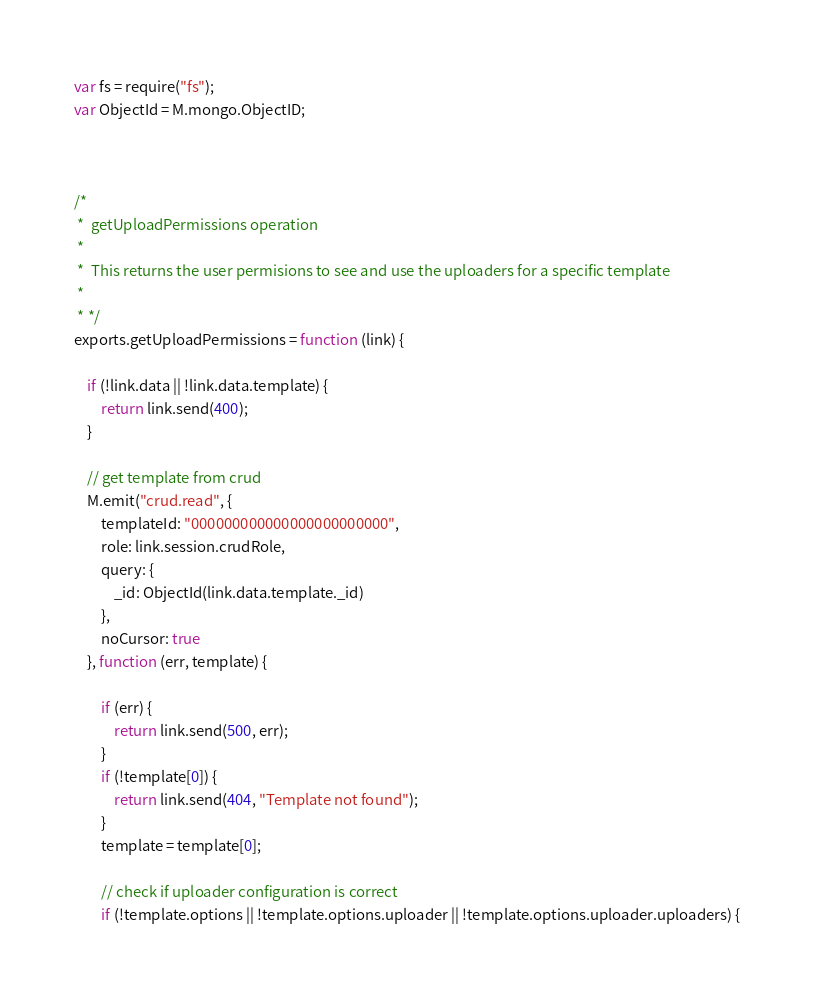Convert code to text. <code><loc_0><loc_0><loc_500><loc_500><_JavaScript_>var fs = require("fs");
var ObjectId = M.mongo.ObjectID;



/*
 *  getUploadPermissions operation
 *
 *  This returns the user permisions to see and use the uploaders for a specific template
 *
 * */
exports.getUploadPermissions = function (link) {

    if (!link.data || !link.data.template) {
        return link.send(400);
    }

    // get template from crud
    M.emit("crud.read", {
        templateId: "000000000000000000000000",
        role: link.session.crudRole,
        query: {
            _id: ObjectId(link.data.template._id)
        },
        noCursor: true
    }, function (err, template) {

        if (err) {
            return link.send(500, err);
        }
        if (!template[0]) {
            return link.send(404, "Template not found");
        }
        template = template[0];

        // check if uploader configuration is correct
        if (!template.options || !template.options.uploader || !template.options.uploader.uploaders) {</code> 